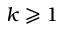<formula> <loc_0><loc_0><loc_500><loc_500>k \geqslant 1</formula> 